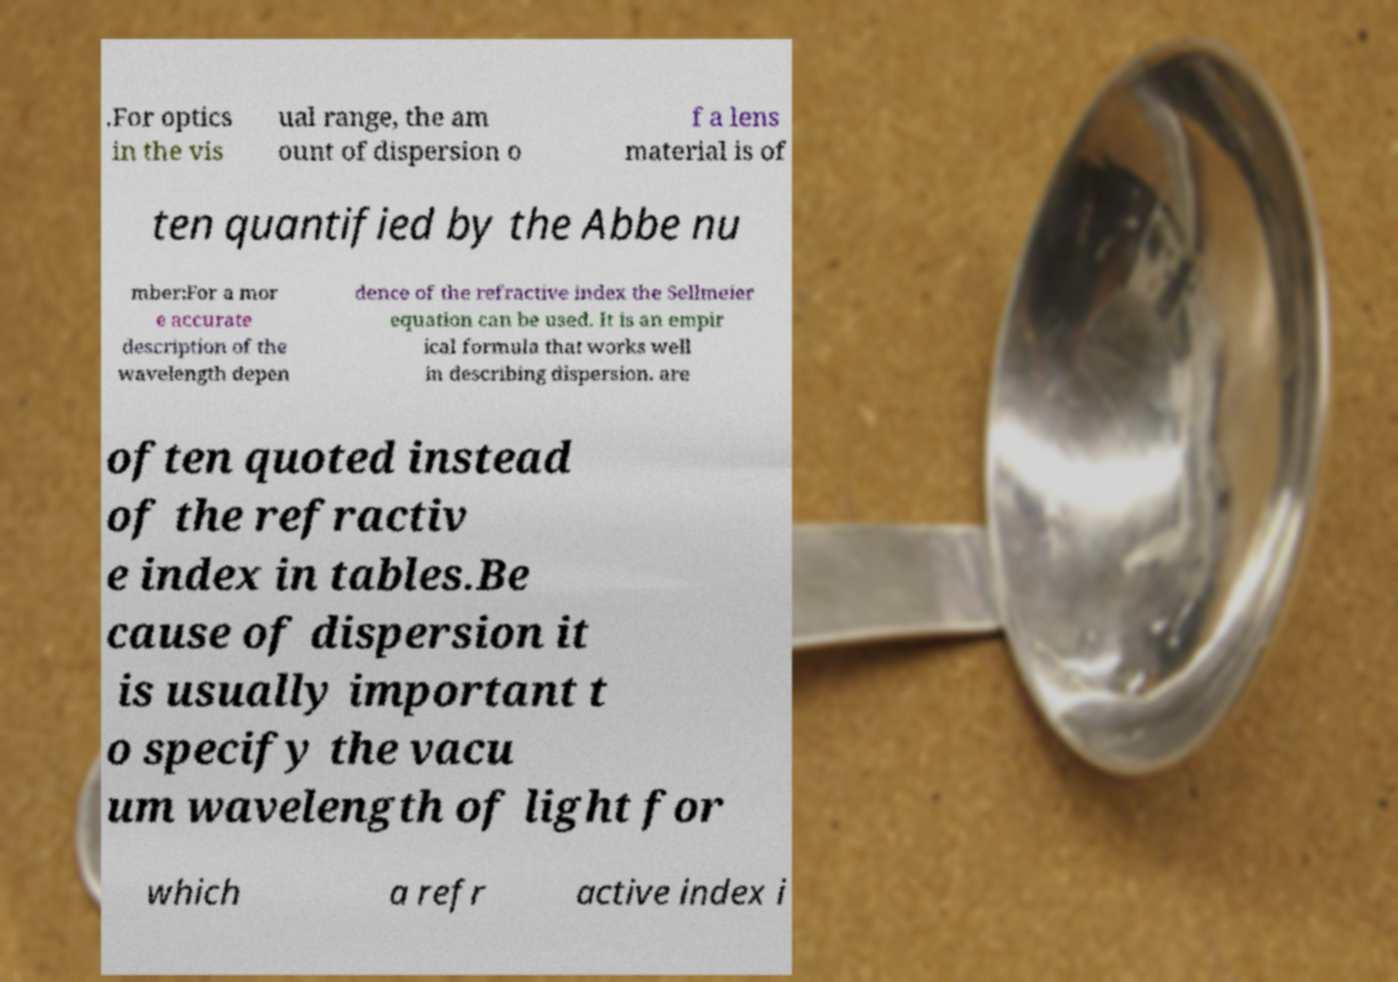What messages or text are displayed in this image? I need them in a readable, typed format. .For optics in the vis ual range, the am ount of dispersion o f a lens material is of ten quantified by the Abbe nu mber:For a mor e accurate description of the wavelength depen dence of the refractive index the Sellmeier equation can be used. It is an empir ical formula that works well in describing dispersion. are often quoted instead of the refractiv e index in tables.Be cause of dispersion it is usually important t o specify the vacu um wavelength of light for which a refr active index i 